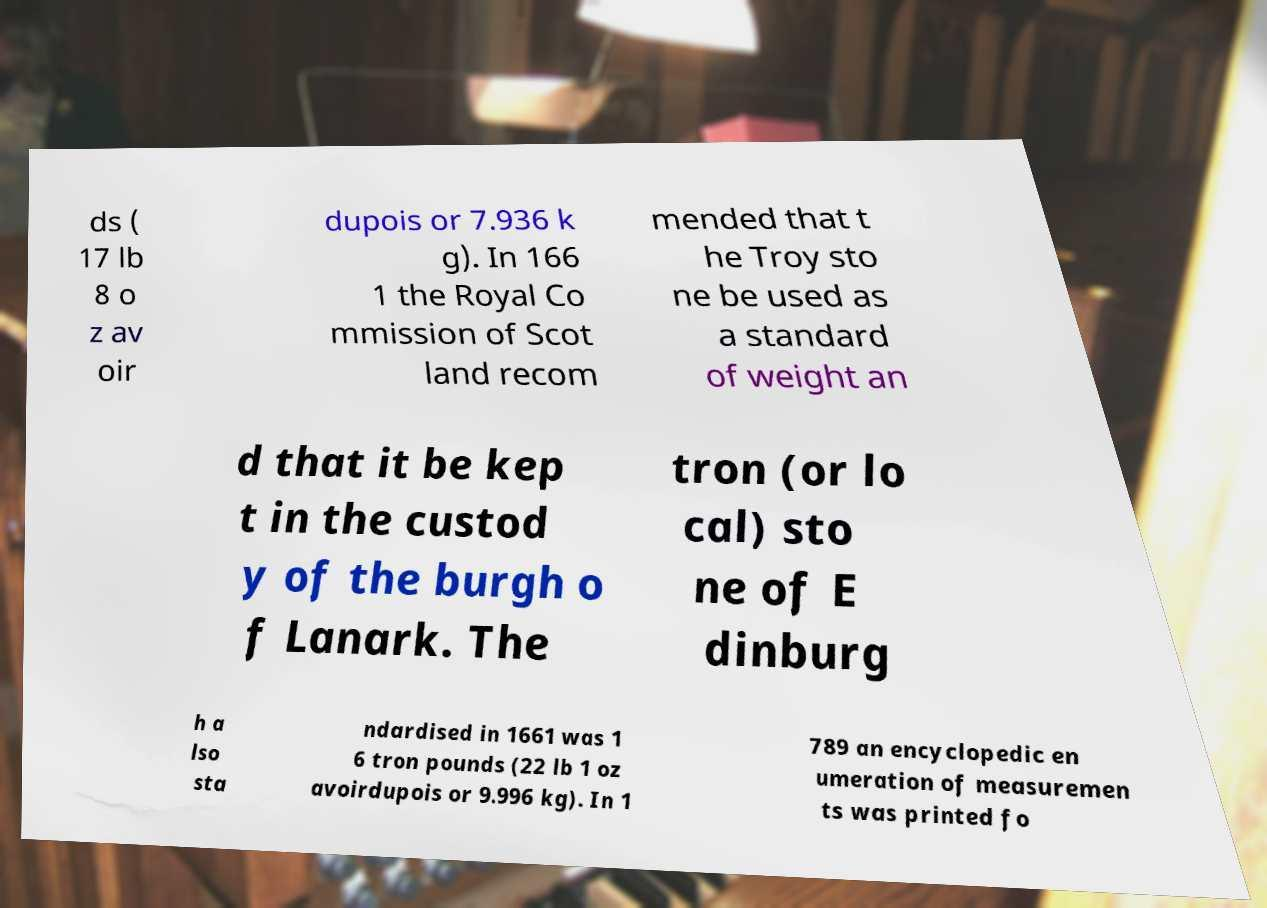There's text embedded in this image that I need extracted. Can you transcribe it verbatim? ds ( 17 lb 8 o z av oir dupois or 7.936 k g). In 166 1 the Royal Co mmission of Scot land recom mended that t he Troy sto ne be used as a standard of weight an d that it be kep t in the custod y of the burgh o f Lanark. The tron (or lo cal) sto ne of E dinburg h a lso sta ndardised in 1661 was 1 6 tron pounds (22 lb 1 oz avoirdupois or 9.996 kg). In 1 789 an encyclopedic en umeration of measuremen ts was printed fo 